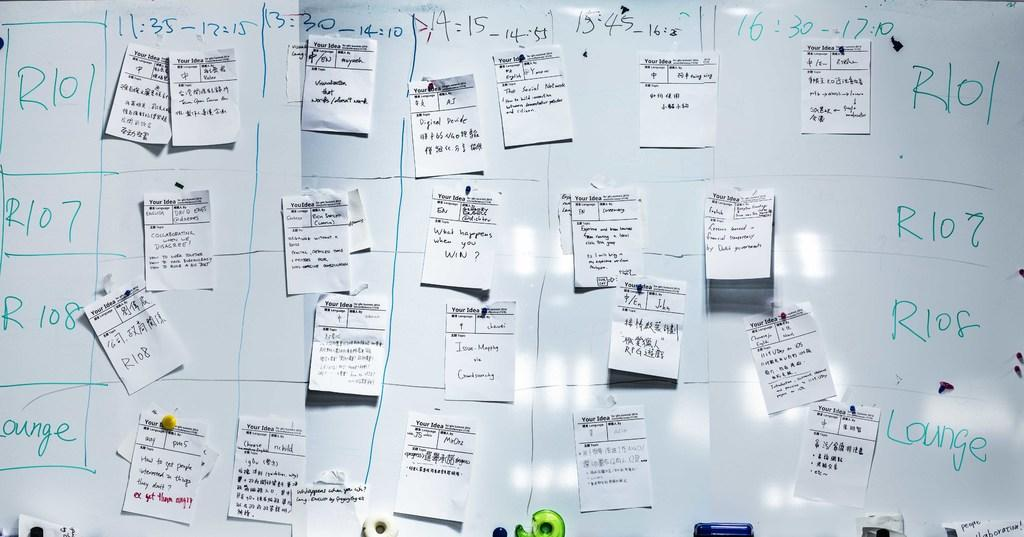Provide a one-sentence caption for the provided image. A whiteboard is divided into sections with various labels that start with R and has paper notes taped on it. 